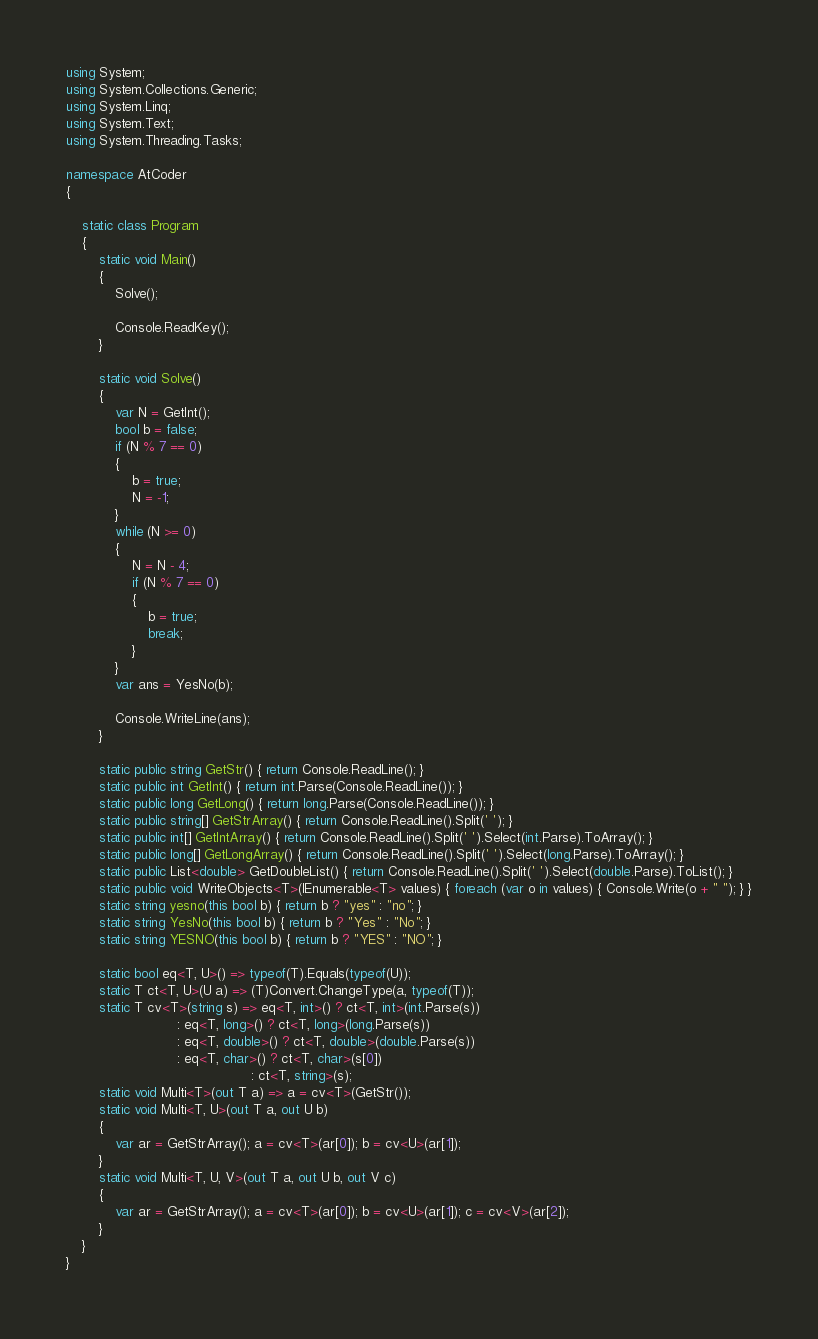Convert code to text. <code><loc_0><loc_0><loc_500><loc_500><_C#_>using System;
using System.Collections.Generic;
using System.Linq;
using System.Text;
using System.Threading.Tasks;

namespace AtCoder
{

    static class Program
    {
        static void Main()
        {
            Solve();

            Console.ReadKey();
        }

        static void Solve()
        {
            var N = GetInt();
            bool b = false;
            if (N % 7 == 0)
            {
                b = true;
                N = -1;
            }
            while (N >= 0)
            {
                N = N - 4;
                if (N % 7 == 0)
                {
                    b = true;
                    break;
                }
            }
            var ans = YesNo(b);

            Console.WriteLine(ans);
        }

        static public string GetStr() { return Console.ReadLine(); }
        static public int GetInt() { return int.Parse(Console.ReadLine()); }
        static public long GetLong() { return long.Parse(Console.ReadLine()); }
        static public string[] GetStrArray() { return Console.ReadLine().Split(' '); }
        static public int[] GetIntArray() { return Console.ReadLine().Split(' ').Select(int.Parse).ToArray(); }
        static public long[] GetLongArray() { return Console.ReadLine().Split(' ').Select(long.Parse).ToArray(); }
        static public List<double> GetDoubleList() { return Console.ReadLine().Split(' ').Select(double.Parse).ToList(); }
        static public void WriteObjects<T>(IEnumerable<T> values) { foreach (var o in values) { Console.Write(o + " "); } }
        static string yesno(this bool b) { return b ? "yes" : "no"; }
        static string YesNo(this bool b) { return b ? "Yes" : "No"; }
        static string YESNO(this bool b) { return b ? "YES" : "NO"; }

        static bool eq<T, U>() => typeof(T).Equals(typeof(U));
        static T ct<T, U>(U a) => (T)Convert.ChangeType(a, typeof(T));
        static T cv<T>(string s) => eq<T, int>() ? ct<T, int>(int.Parse(s))
                           : eq<T, long>() ? ct<T, long>(long.Parse(s))
                           : eq<T, double>() ? ct<T, double>(double.Parse(s))
                           : eq<T, char>() ? ct<T, char>(s[0])
                                             : ct<T, string>(s);
        static void Multi<T>(out T a) => a = cv<T>(GetStr());
        static void Multi<T, U>(out T a, out U b)
        {
            var ar = GetStrArray(); a = cv<T>(ar[0]); b = cv<U>(ar[1]);
        }
        static void Multi<T, U, V>(out T a, out U b, out V c)
        {
            var ar = GetStrArray(); a = cv<T>(ar[0]); b = cv<U>(ar[1]); c = cv<V>(ar[2]);
        }
    }
}</code> 